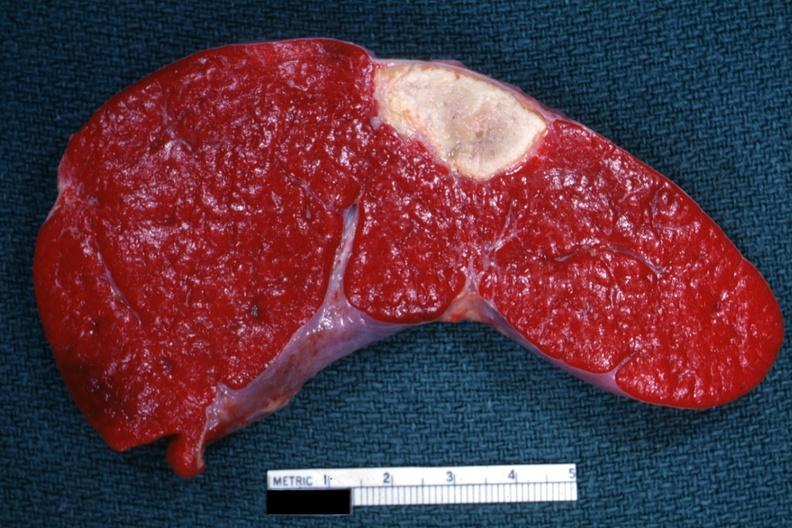does this image show excellent example of old spleen infarct?
Answer the question using a single word or phrase. Yes 